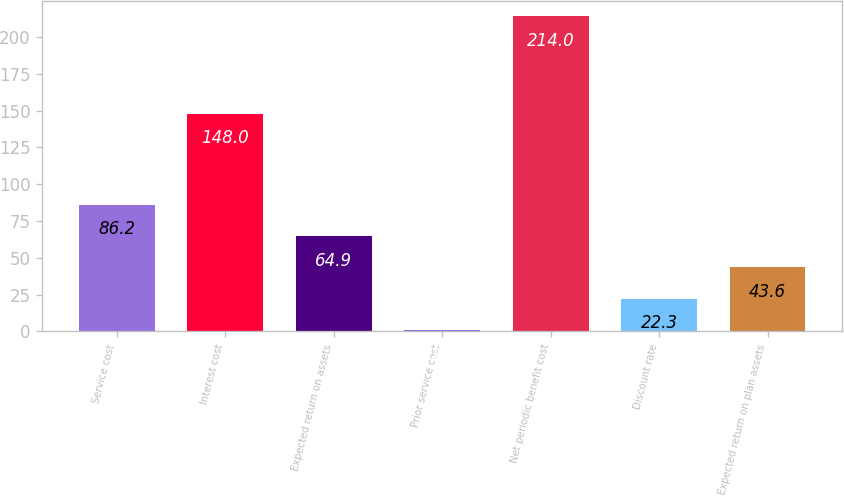Convert chart. <chart><loc_0><loc_0><loc_500><loc_500><bar_chart><fcel>Service cost<fcel>Interest cost<fcel>Expected return on assets<fcel>Prior service cost<fcel>Net periodic benefit cost<fcel>Discount rate<fcel>Expected return on plan assets<nl><fcel>86.2<fcel>148<fcel>64.9<fcel>1<fcel>214<fcel>22.3<fcel>43.6<nl></chart> 